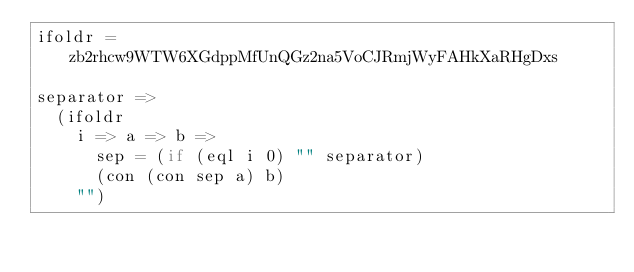<code> <loc_0><loc_0><loc_500><loc_500><_MoonScript_>ifoldr = zb2rhcw9WTW6XGdppMfUnQGz2na5VoCJRmjWyFAHkXaRHgDxs

separator =>
  (ifoldr
    i => a => b =>
      sep = (if (eql i 0) "" separator)
      (con (con sep a) b)
    "")
</code> 